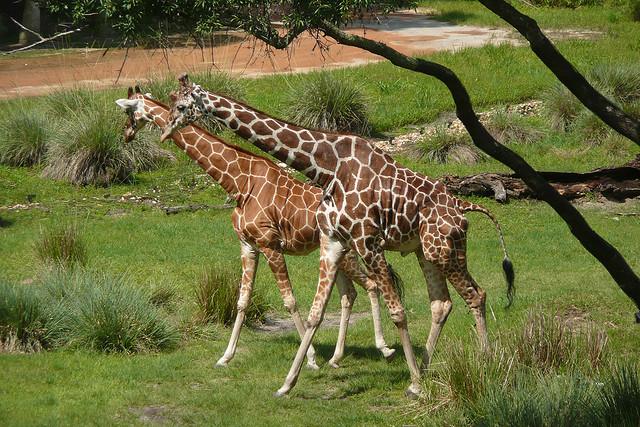<image>Where are the two zebras in the picture? I don't know where the zebras are. They may not be in the picture. Where are the two zebras in the picture? There are no zebras in the picture. 